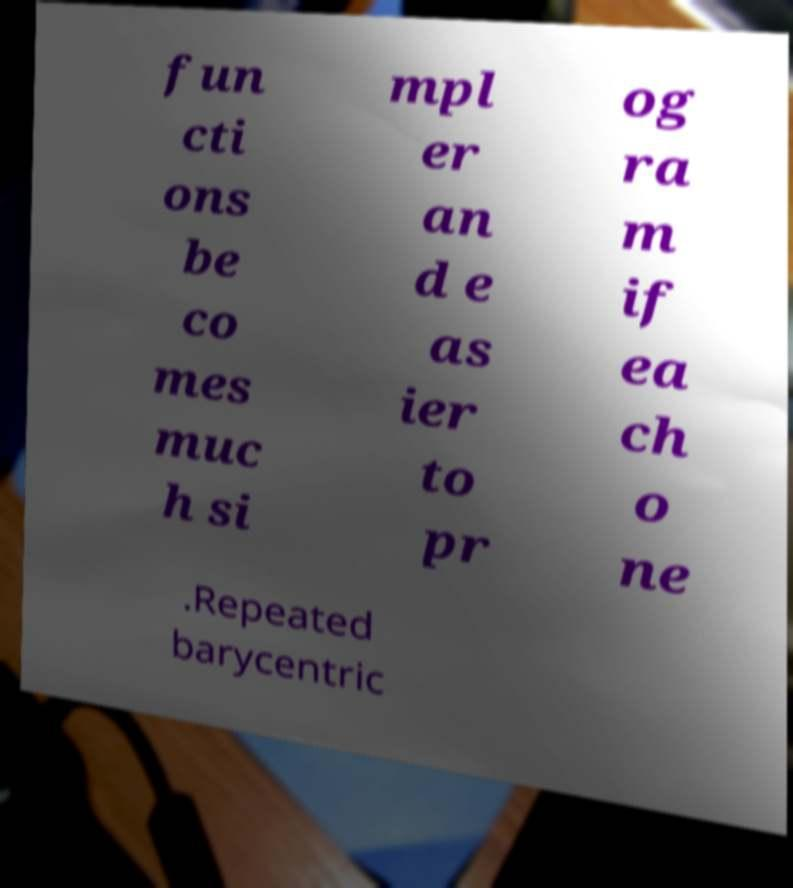Can you accurately transcribe the text from the provided image for me? fun cti ons be co mes muc h si mpl er an d e as ier to pr og ra m if ea ch o ne .Repeated barycentric 